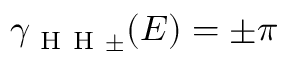Convert formula to latex. <formula><loc_0><loc_0><loc_500><loc_500>\gamma _ { H H \pm } ( E ) = \pm \pi</formula> 